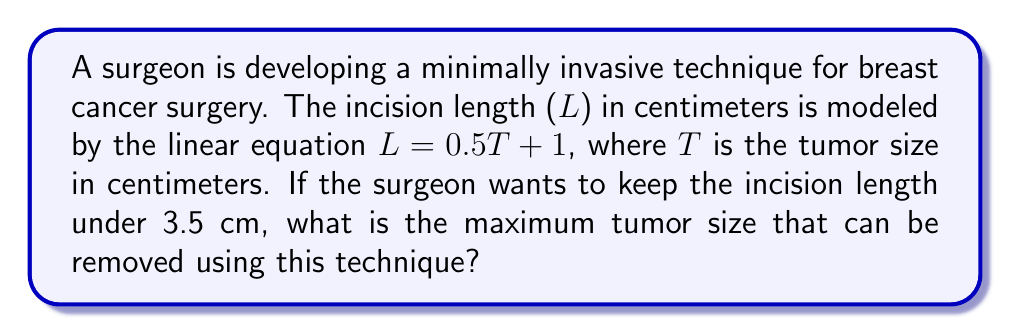Can you solve this math problem? To solve this problem, we'll follow these steps:

1) We're given the linear equation: $L = 0.5T + 1$
   Where L is the incision length and T is the tumor size.

2) We want to find the maximum tumor size (T) when the incision length (L) is just under 3.5 cm.
   So, we'll set L to 3.5 and solve for T:

   $3.5 = 0.5T + 1$

3) Subtract 1 from both sides:
   $2.5 = 0.5T$

4) Multiply both sides by 2 to isolate T:
   $5 = T$

5) Therefore, the maximum tumor size that can be removed with an incision length under 3.5 cm is 5 cm.

To verify:
If T = 5, then L = 0.5(5) + 1 = 3.5 cm, which is the maximum allowed incision length.

[asy]
size(200,200);
real xmax = 6;
real ymax = 4;
real xstep = xmax/6;
real ystep = ymax/4;

for (int i=0; i <= xmax; i+=xstep)
  draw((i,0)--(i,ymax),gray+opacity(0.5));
for (int i=0; i <= ymax; i+=ystep)
  draw((0,i)--(xmax,i),gray+opacity(0.5));

draw((0,0)--(xmax,0),arrow=Arrow(TeXHead));
draw((0,0)--(0,ymax),arrow=Arrow(TeXHead));

label("Tumor size (cm)",((xmax,0)),S);
label("Incision length (cm)",(0,ymax),W);

draw((0,1)--(xmax,0.5*xmax+1),blue);
dot((5,3.5),red);
label("(5, 3.5)",(5,3.5),NE);

for (int i=0; i <= xmax; i+=xstep)
  label(string(i),(i,0),S);
for (int i=0; i <= ymax; i+=ystep)
  label(string(i),(0,i),W);
[/asy]
Answer: 5 cm 